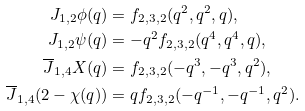Convert formula to latex. <formula><loc_0><loc_0><loc_500><loc_500>J _ { 1 , 2 } \phi ( q ) & = f _ { 2 , 3 , 2 } ( q ^ { 2 } , q ^ { 2 } , q ) , \\ J _ { 1 , 2 } \psi ( q ) & = - q ^ { 2 } f _ { 2 , 3 , 2 } ( q ^ { 4 } , q ^ { 4 } , q ) , \\ \overline { J } _ { 1 , 4 } X ( q ) & = f _ { 2 , 3 , 2 } ( - q ^ { 3 } , - q ^ { 3 } , q ^ { 2 } ) , \\ \overline { J } _ { 1 , 4 } ( 2 - \chi ( q ) ) & = q f _ { 2 , 3 , 2 } ( - q ^ { - 1 } , - q ^ { - 1 } , q ^ { 2 } ) .</formula> 